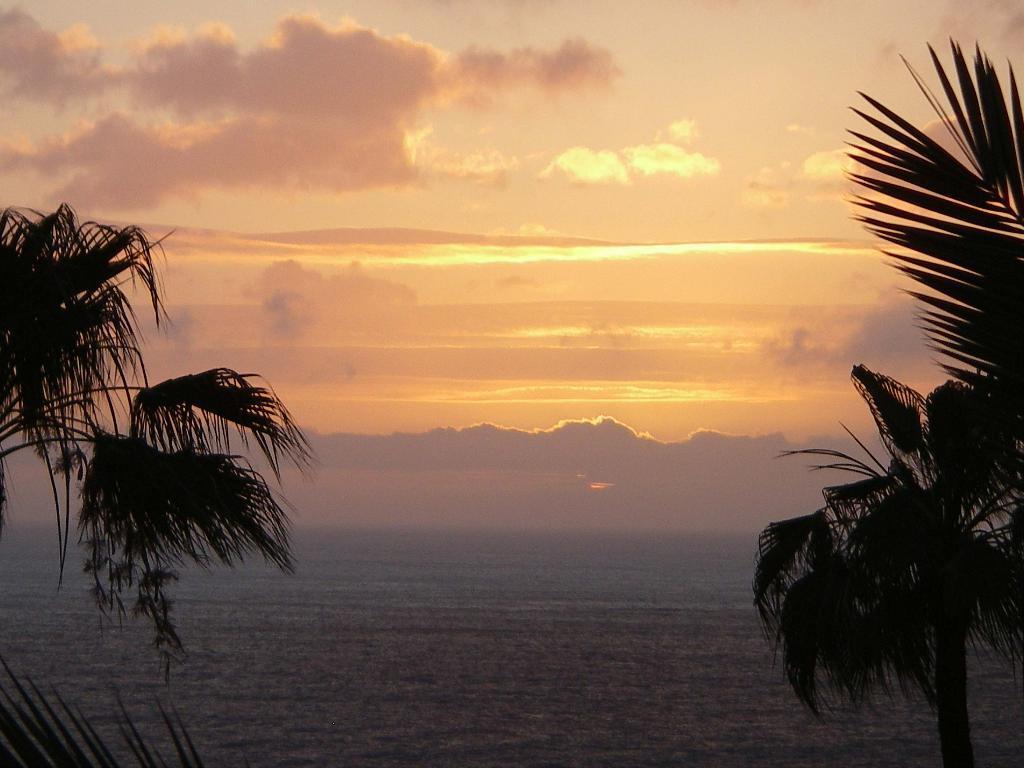Could you give a brief overview of what you see in this image? In the picture we can see two trees on the either side of the picture and water, in the background, we can see a sky and clouds with a sunshine. 